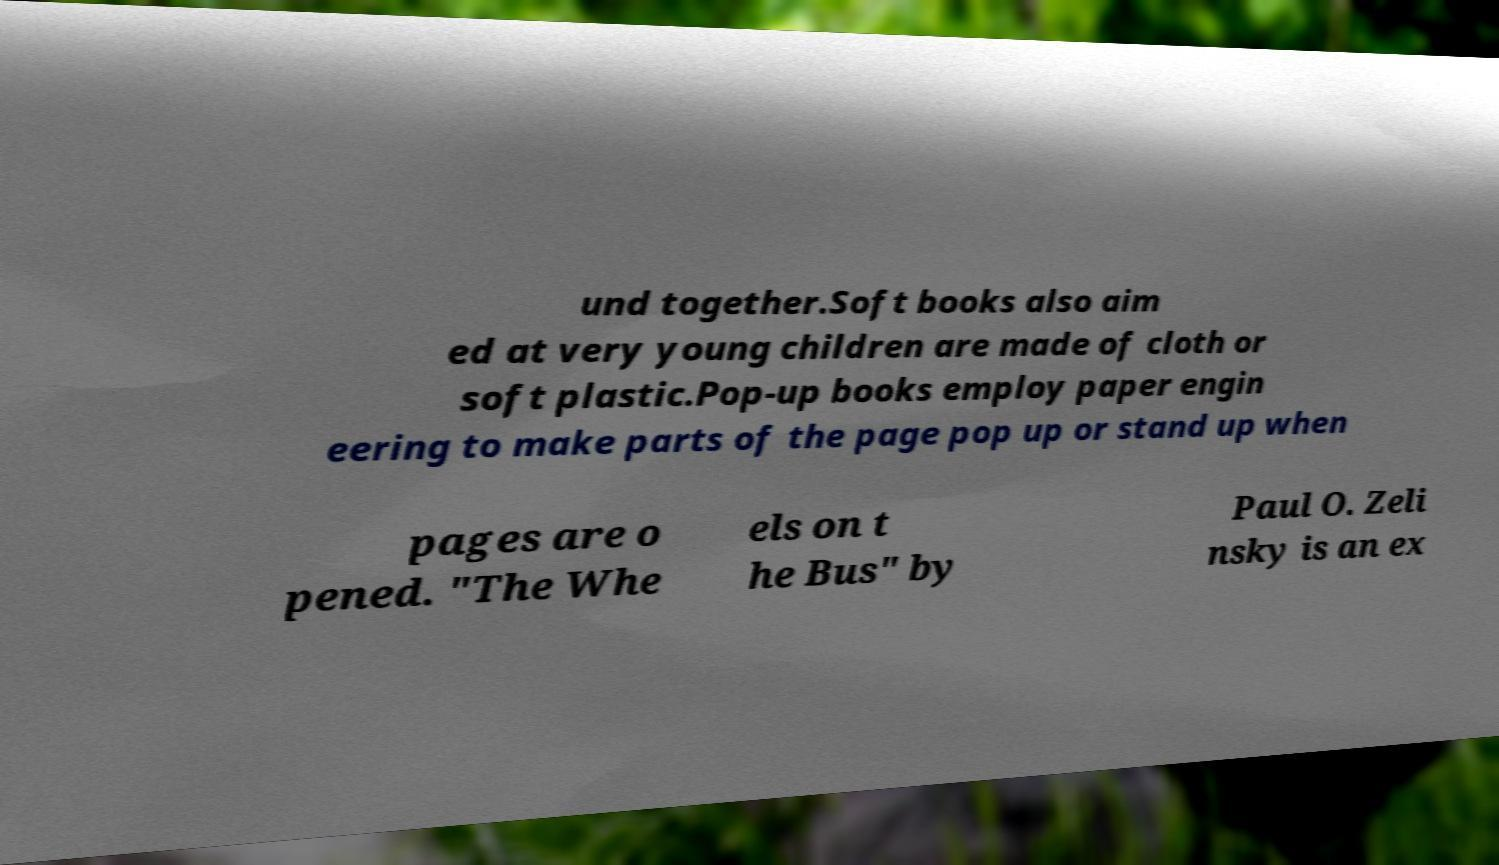Could you extract and type out the text from this image? und together.Soft books also aim ed at very young children are made of cloth or soft plastic.Pop-up books employ paper engin eering to make parts of the page pop up or stand up when pages are o pened. "The Whe els on t he Bus" by Paul O. Zeli nsky is an ex 